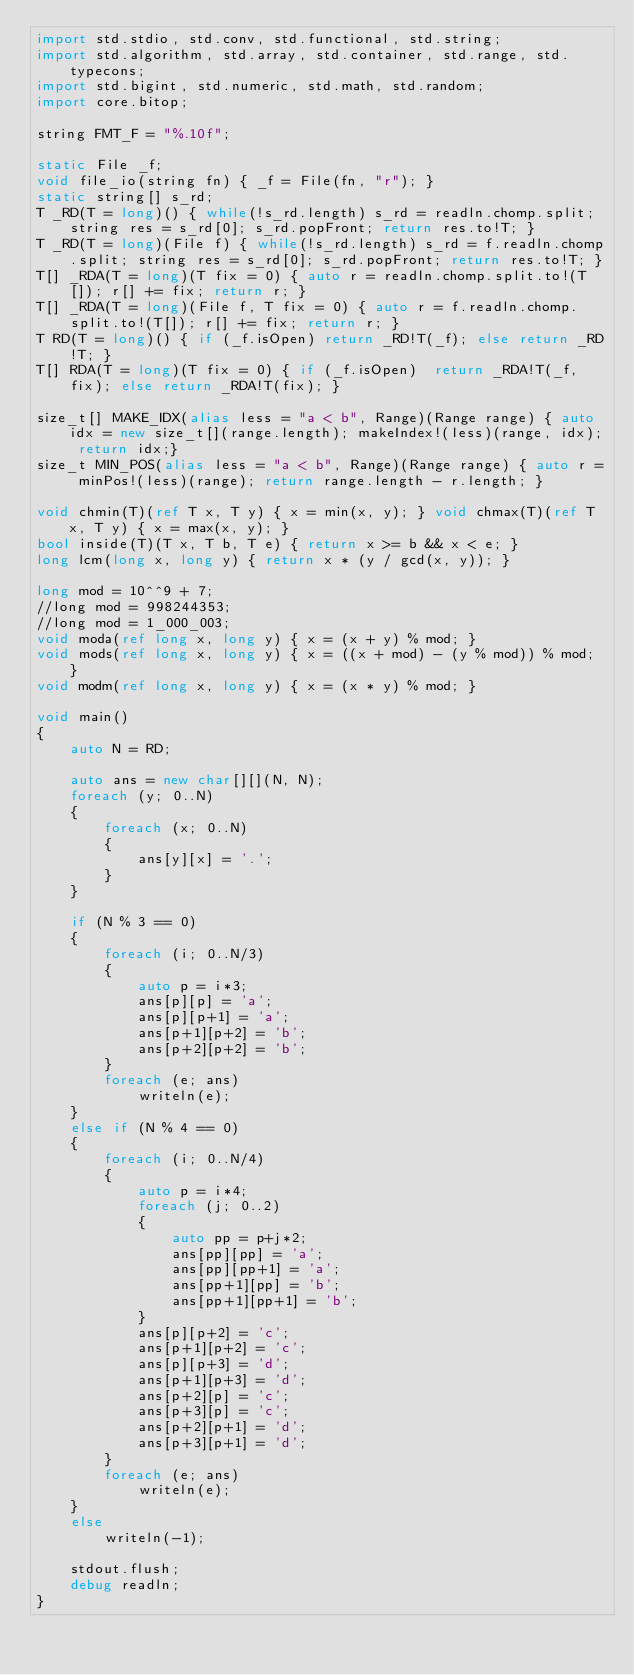<code> <loc_0><loc_0><loc_500><loc_500><_D_>import std.stdio, std.conv, std.functional, std.string;
import std.algorithm, std.array, std.container, std.range, std.typecons;
import std.bigint, std.numeric, std.math, std.random;
import core.bitop;

string FMT_F = "%.10f";

static File _f;
void file_io(string fn) { _f = File(fn, "r"); }
static string[] s_rd;
T _RD(T = long)() { while(!s_rd.length) s_rd = readln.chomp.split; string res = s_rd[0]; s_rd.popFront; return res.to!T; }
T _RD(T = long)(File f) { while(!s_rd.length) s_rd = f.readln.chomp.split; string res = s_rd[0]; s_rd.popFront; return res.to!T; }
T[] _RDA(T = long)(T fix = 0) { auto r = readln.chomp.split.to!(T[]); r[] += fix; return r; }
T[] _RDA(T = long)(File f, T fix = 0) { auto r = f.readln.chomp.split.to!(T[]); r[] += fix; return r; }
T RD(T = long)() { if (_f.isOpen) return _RD!T(_f); else return _RD!T; }
T[] RDA(T = long)(T fix = 0) { if (_f.isOpen)  return _RDA!T(_f, fix); else return _RDA!T(fix); }

size_t[] MAKE_IDX(alias less = "a < b", Range)(Range range) { auto idx = new size_t[](range.length); makeIndex!(less)(range, idx); return idx;}
size_t MIN_POS(alias less = "a < b", Range)(Range range) { auto r = minPos!(less)(range); return range.length - r.length; }

void chmin(T)(ref T x, T y) { x = min(x, y); } void chmax(T)(ref T x, T y) { x = max(x, y); }
bool inside(T)(T x, T b, T e) { return x >= b && x < e; }
long lcm(long x, long y) { return x * (y / gcd(x, y)); }

long mod = 10^^9 + 7;
//long mod = 998244353;
//long mod = 1_000_003;
void moda(ref long x, long y) { x = (x + y) % mod; }
void mods(ref long x, long y) { x = ((x + mod) - (y % mod)) % mod; }
void modm(ref long x, long y) { x = (x * y) % mod; }

void main()
{
	auto N = RD;

	auto ans = new char[][](N, N);
	foreach (y; 0..N)
	{
		foreach (x; 0..N)
		{
			ans[y][x] = '.';
		}
	}

	if (N % 3 == 0)
	{
		foreach (i; 0..N/3)
		{
			auto p = i*3;
			ans[p][p] = 'a';
			ans[p][p+1] = 'a';
			ans[p+1][p+2] = 'b';
			ans[p+2][p+2] = 'b';
		}
		foreach (e; ans)
			writeln(e);
	}
	else if (N % 4 == 0)
	{
		foreach (i; 0..N/4)
		{
			auto p = i*4;
			foreach (j; 0..2)
			{
				auto pp = p+j*2;
				ans[pp][pp] = 'a';
				ans[pp][pp+1] = 'a';
				ans[pp+1][pp] = 'b';
				ans[pp+1][pp+1] = 'b';
			}
			ans[p][p+2] = 'c';
			ans[p+1][p+2] = 'c';
			ans[p][p+3] = 'd';
			ans[p+1][p+3] = 'd';
			ans[p+2][p] = 'c';
			ans[p+3][p] = 'c';
			ans[p+2][p+1] = 'd';
			ans[p+3][p+1] = 'd';
		}
		foreach (e; ans)
			writeln(e);
	}
	else
		writeln(-1);
	
	stdout.flush;
	debug readln;
}</code> 